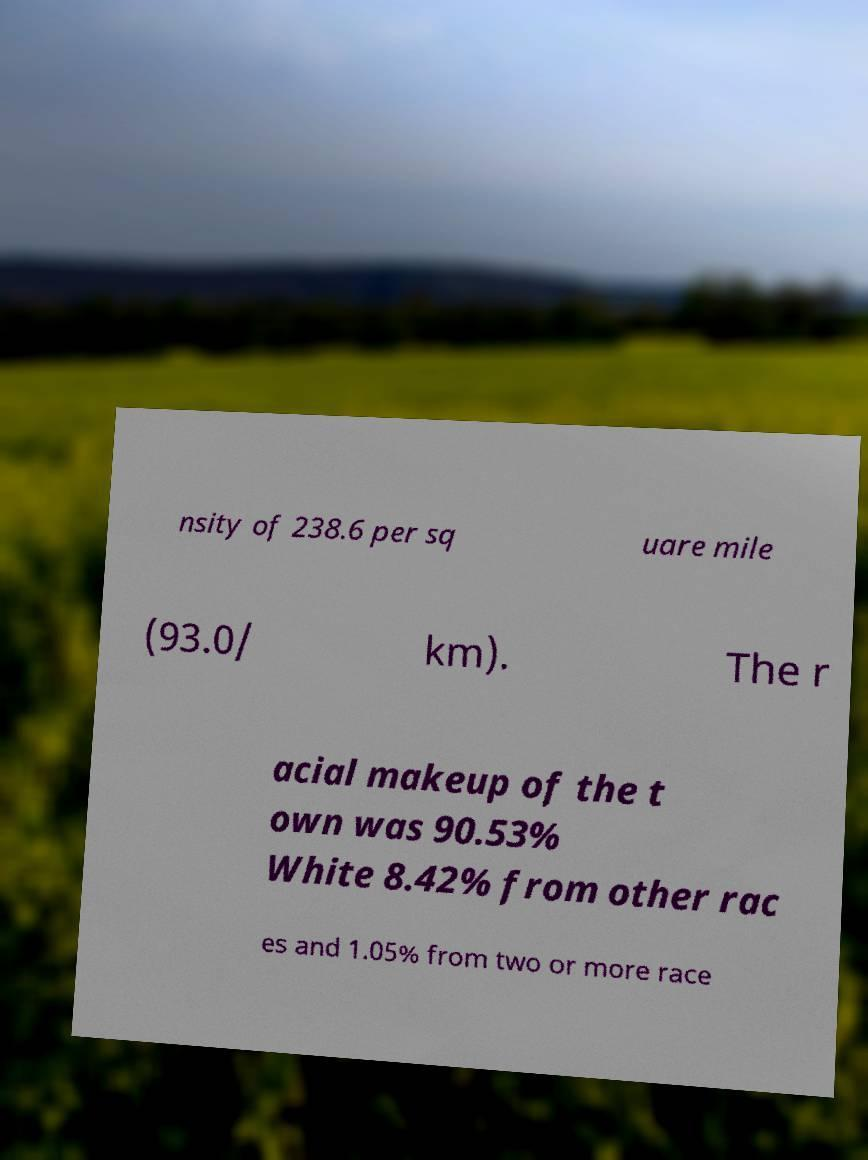For documentation purposes, I need the text within this image transcribed. Could you provide that? nsity of 238.6 per sq uare mile (93.0/ km). The r acial makeup of the t own was 90.53% White 8.42% from other rac es and 1.05% from two or more race 